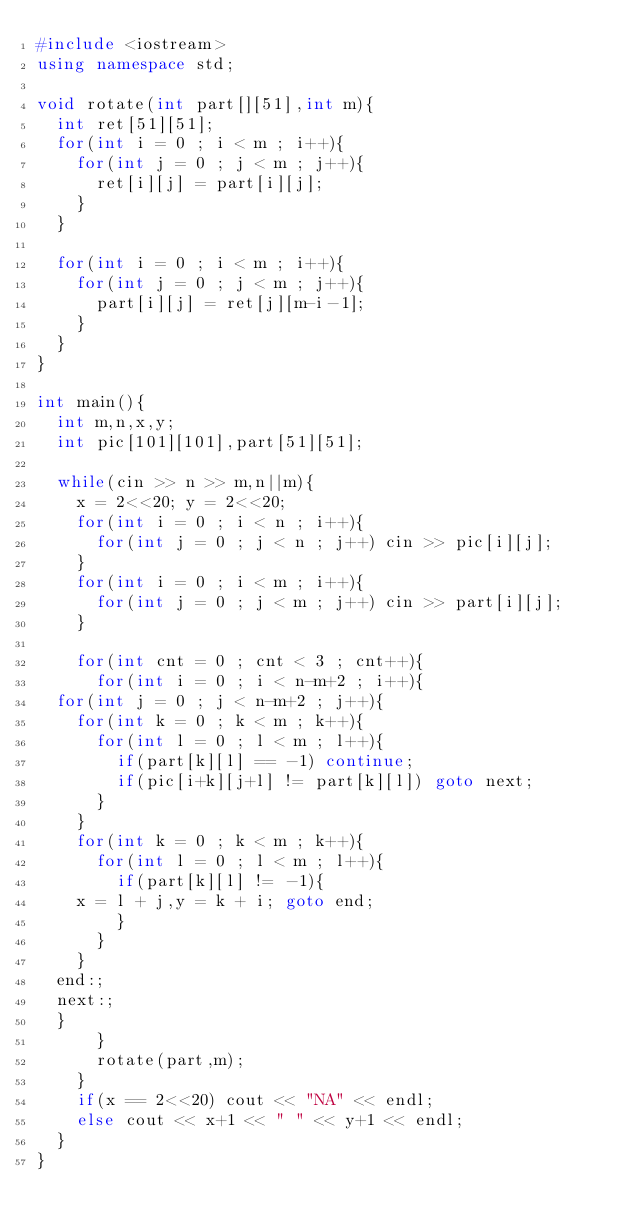<code> <loc_0><loc_0><loc_500><loc_500><_C++_>#include <iostream>
using namespace std;

void rotate(int part[][51],int m){
  int ret[51][51];
  for(int i = 0 ; i < m ; i++){
    for(int j = 0 ; j < m ; j++){
      ret[i][j] = part[i][j];
    }
  }

  for(int i = 0 ; i < m ; i++){
    for(int j = 0 ; j < m ; j++){
      part[i][j] = ret[j][m-i-1];
    }
  }
}

int main(){
  int m,n,x,y;
  int pic[101][101],part[51][51];
   
  while(cin >> n >> m,n||m){
    x = 2<<20; y = 2<<20;
    for(int i = 0 ; i < n ; i++){
      for(int j = 0 ; j < n ; j++) cin >> pic[i][j];
    }
    for(int i = 0 ; i < m ; i++){
      for(int j = 0 ; j < m ; j++) cin >> part[i][j];
    }
    
    for(int cnt = 0 ; cnt < 3 ; cnt++){
      for(int i = 0 ; i < n-m+2 ; i++){
	for(int j = 0 ; j < n-m+2 ; j++){
	  for(int k = 0 ; k < m ; k++){
	    for(int l = 0 ; l < m ; l++){
	      if(part[k][l] == -1) continue;
	      if(pic[i+k][j+l] != part[k][l]) goto next;
	    }
	  }
	  for(int k = 0 ; k < m ; k++){
	    for(int l = 0 ; l < m ; l++){
	      if(part[k][l] != -1){
		x = l + j,y = k + i; goto end;
	      }
	    }
	  }
	end:;
	next:;
	}
      }
      rotate(part,m);
    }
    if(x == 2<<20) cout << "NA" << endl;
    else cout << x+1 << " " << y+1 << endl;
  }
}</code> 